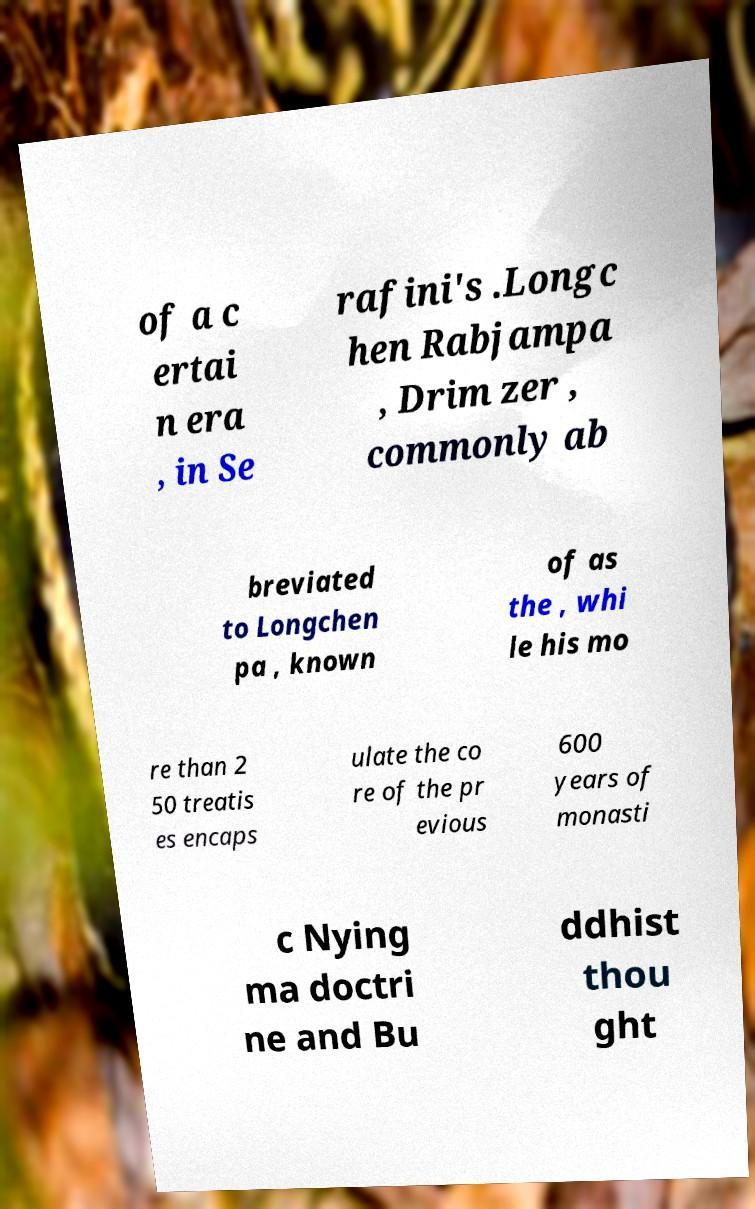Please identify and transcribe the text found in this image. of a c ertai n era , in Se rafini's .Longc hen Rabjampa , Drim zer , commonly ab breviated to Longchen pa , known of as the , whi le his mo re than 2 50 treatis es encaps ulate the co re of the pr evious 600 years of monasti c Nying ma doctri ne and Bu ddhist thou ght 